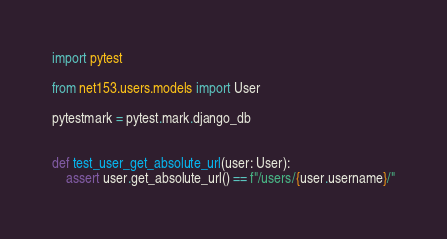Convert code to text. <code><loc_0><loc_0><loc_500><loc_500><_Python_>import pytest

from net153.users.models import User

pytestmark = pytest.mark.django_db


def test_user_get_absolute_url(user: User):
    assert user.get_absolute_url() == f"/users/{user.username}/"
</code> 